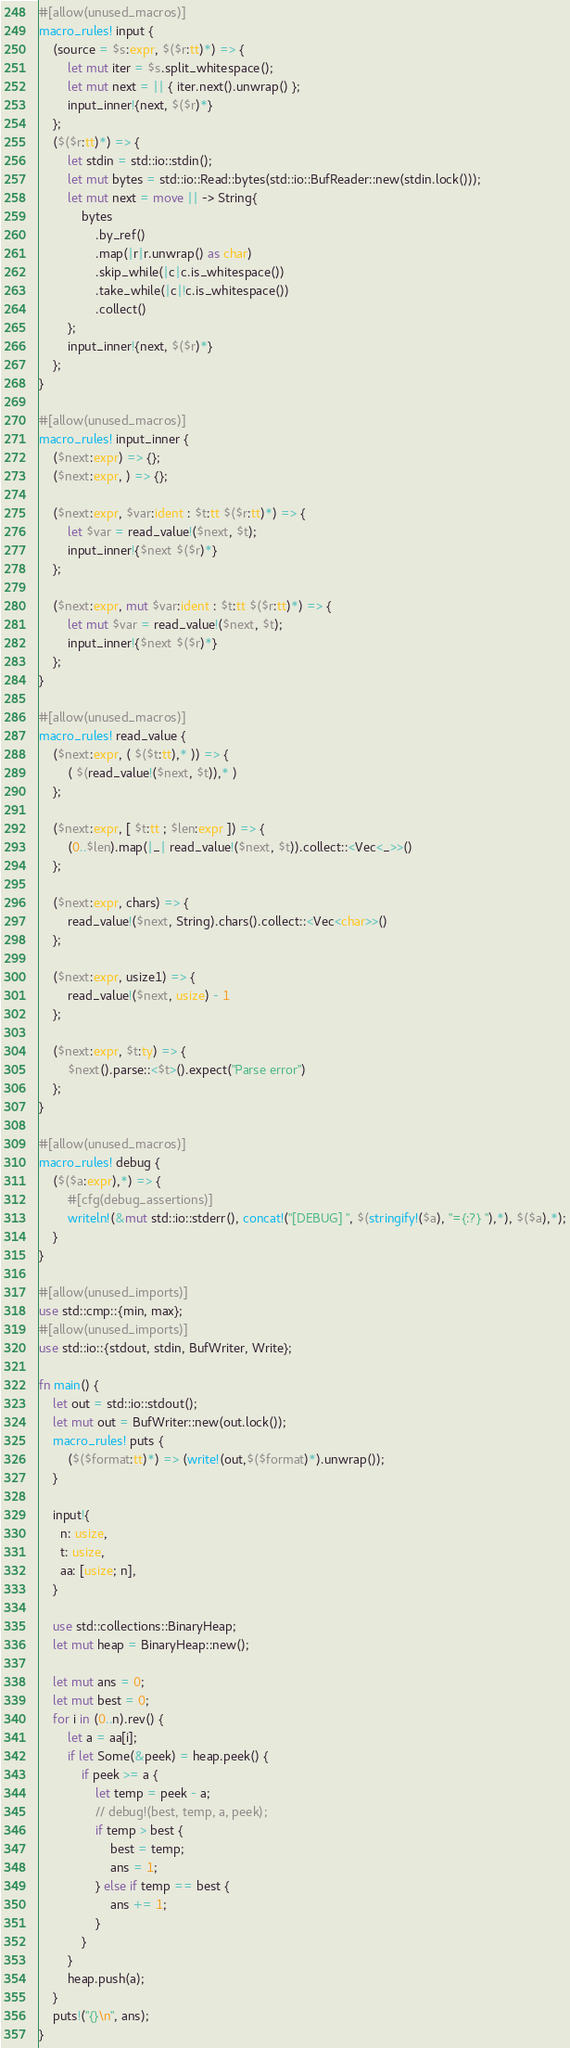<code> <loc_0><loc_0><loc_500><loc_500><_Rust_>#[allow(unused_macros)]
macro_rules! input {
    (source = $s:expr, $($r:tt)*) => {
        let mut iter = $s.split_whitespace();
        let mut next = || { iter.next().unwrap() };
        input_inner!{next, $($r)*}
    };
    ($($r:tt)*) => {
        let stdin = std::io::stdin();
        let mut bytes = std::io::Read::bytes(std::io::BufReader::new(stdin.lock()));
        let mut next = move || -> String{
            bytes
                .by_ref()
                .map(|r|r.unwrap() as char)
                .skip_while(|c|c.is_whitespace())
                .take_while(|c|!c.is_whitespace())
                .collect()
        };
        input_inner!{next, $($r)*}
    };
}

#[allow(unused_macros)]
macro_rules! input_inner {
    ($next:expr) => {};
    ($next:expr, ) => {};

    ($next:expr, $var:ident : $t:tt $($r:tt)*) => {
        let $var = read_value!($next, $t);
        input_inner!{$next $($r)*}
    };

    ($next:expr, mut $var:ident : $t:tt $($r:tt)*) => {
        let mut $var = read_value!($next, $t);
        input_inner!{$next $($r)*}
    };
}

#[allow(unused_macros)]
macro_rules! read_value {
    ($next:expr, ( $($t:tt),* )) => {
        ( $(read_value!($next, $t)),* )
    };

    ($next:expr, [ $t:tt ; $len:expr ]) => {
        (0..$len).map(|_| read_value!($next, $t)).collect::<Vec<_>>()
    };

    ($next:expr, chars) => {
        read_value!($next, String).chars().collect::<Vec<char>>()
    };

    ($next:expr, usize1) => {
        read_value!($next, usize) - 1
    };

    ($next:expr, $t:ty) => {
        $next().parse::<$t>().expect("Parse error")
    };
}

#[allow(unused_macros)]
macro_rules! debug {
    ($($a:expr),*) => {
        #[cfg(debug_assertions)]
        writeln!(&mut std::io::stderr(), concat!("[DEBUG] ", $(stringify!($a), "={:?} "),*), $($a),*);
    }
}

#[allow(unused_imports)]
use std::cmp::{min, max};
#[allow(unused_imports)]
use std::io::{stdout, stdin, BufWriter, Write};

fn main() {
    let out = std::io::stdout();
    let mut out = BufWriter::new(out.lock());
    macro_rules! puts {
        ($($format:tt)*) => (write!(out,$($format)*).unwrap());
    }

    input!{
      n: usize,
      t: usize,
      aa: [usize; n],
    }

    use std::collections::BinaryHeap;
    let mut heap = BinaryHeap::new();

    let mut ans = 0;
    let mut best = 0;
    for i in (0..n).rev() {
        let a = aa[i];
        if let Some(&peek) = heap.peek() {
            if peek >= a {
                let temp = peek - a;
                // debug!(best, temp, a, peek);
                if temp > best {
                    best = temp;
                    ans = 1;
                } else if temp == best {
                    ans += 1;
                }
            }
        }
        heap.push(a);
    }
    puts!("{}\n", ans);
}
</code> 